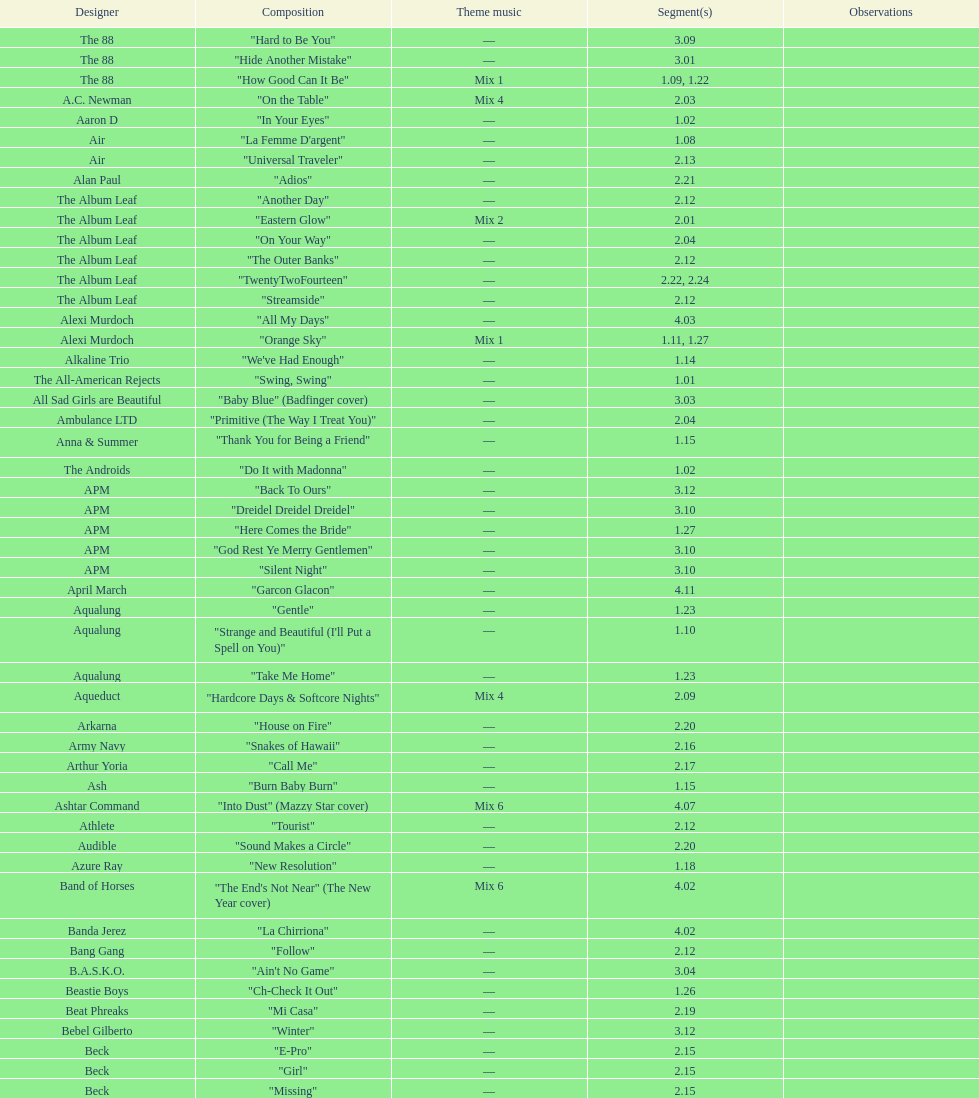How many consecutive songs were by the album leaf? 6. 